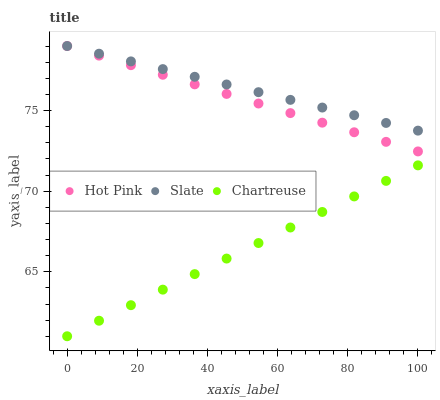Does Chartreuse have the minimum area under the curve?
Answer yes or no. Yes. Does Slate have the maximum area under the curve?
Answer yes or no. Yes. Does Hot Pink have the minimum area under the curve?
Answer yes or no. No. Does Hot Pink have the maximum area under the curve?
Answer yes or no. No. Is Slate the smoothest?
Answer yes or no. Yes. Is Hot Pink the roughest?
Answer yes or no. Yes. Is Chartreuse the smoothest?
Answer yes or no. No. Is Chartreuse the roughest?
Answer yes or no. No. Does Chartreuse have the lowest value?
Answer yes or no. Yes. Does Hot Pink have the lowest value?
Answer yes or no. No. Does Hot Pink have the highest value?
Answer yes or no. Yes. Does Chartreuse have the highest value?
Answer yes or no. No. Is Chartreuse less than Slate?
Answer yes or no. Yes. Is Slate greater than Chartreuse?
Answer yes or no. Yes. Does Hot Pink intersect Slate?
Answer yes or no. Yes. Is Hot Pink less than Slate?
Answer yes or no. No. Is Hot Pink greater than Slate?
Answer yes or no. No. Does Chartreuse intersect Slate?
Answer yes or no. No. 